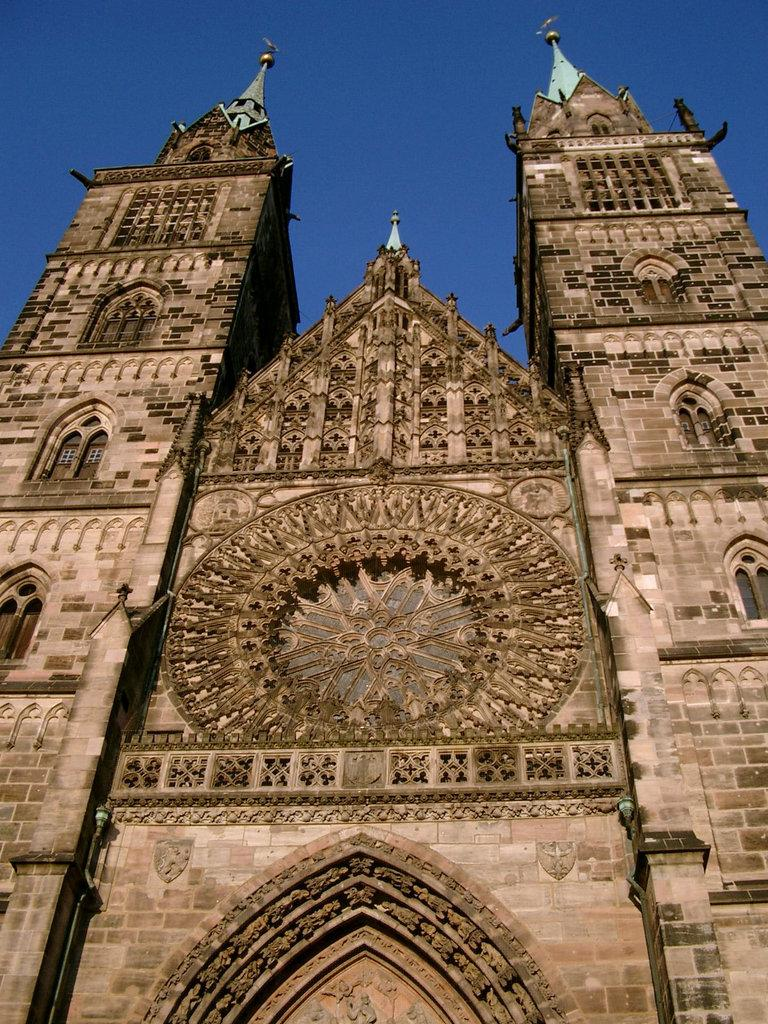What is the main structure in the image? There is a tower in the image. What can be seen at the top of the tower? The sky is visible at the top of the tower. What type of collar is visible on the government building in the image? There is no government building or collar present in the image; it only features a tower. 